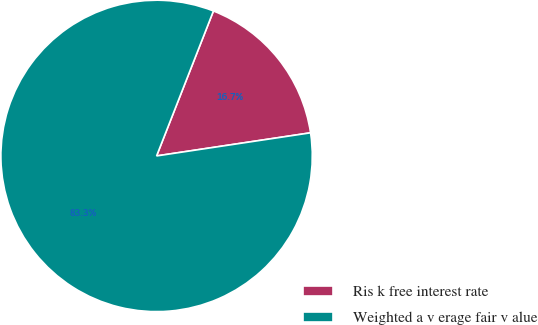Convert chart to OTSL. <chart><loc_0><loc_0><loc_500><loc_500><pie_chart><fcel>Ris k free interest rate<fcel>Weighted a v erage fair v alue<nl><fcel>16.68%<fcel>83.32%<nl></chart> 